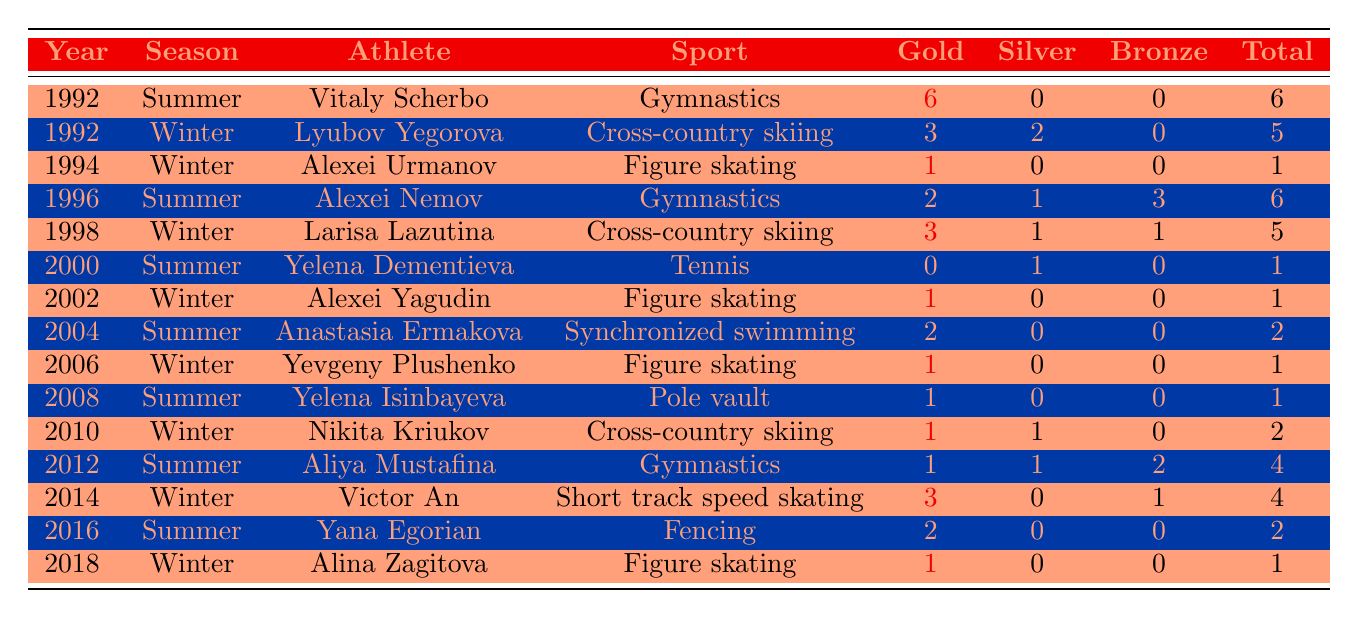What is the total number of gold medals won by Russian athletes in the Summer Olympics? To find the total number of gold medals in the Summer Olympics, we can sum up the Gold column for the rows where the Season is "Summer": 6 (1992) + 2 (1996) + 0 (2000) + 2 (2004) + 1 (2008) + 1 (2012) + 2 (2016) = 14
Answer: 14 Which athlete has the highest total medal count in the Winter Olympics? To identify which athlete has the highest total medal count in the Winter Olympics, we need to look for the maximum value in the Total column for the Season "Winter". The totals are 5 (Lyubov Yegorova), 1 (Alexei Urmanov), 5 (Larisa Lazutina), 1 (Alexei Yagudin), 1 (Yevgeny Plushenko), 2 (Nikita Kriukov), 4 (Victor An), 1 (Alina Zagitova). The highest is 5, held by Lyubov Yegorova and Larisa Lazutina.
Answer: 5 How many more gold medals were won in the Summer Olympics compared to the Winter Olympics? First, we find the total gold medals in Summer Olympics which is 14 (previous calculation). Then, for the Winter Olympics, we sum the Gold column: 3 (Lyubov Yegorova) + 1 (Alexei Urmanov) + 3 (Larisa Lazutina) + 1 (Alexei Yagudin) + 1 (Yevgeny Plushenko) + 1 (Nikita Kriukov) + 3 (Victor An) + 1 (Alina Zagitova) = 12. The difference is 14 - 12 = 2.
Answer: 2 Did any athlete win a gold medal in every season they competed in? We check each athlete in the table for the number of seasons they competed and the number of gold medals: Vitaly Scherbo (1 season, 6 gold), Yelena Dementieva (1 season, 0 gold), Alexei Nemov (1 season, 2 gold), Alexei Yagudin (1 season, 1 gold), and so on. None have competed in multiple seasons and won gold each time. Therefore, the answer is no.
Answer: No What was the total medal count for Aliya Mustafina in the Summer Olympics? For Aliya Mustafina from the Summer Olympics in 2012, her gold, silver, and bronze totals are 1, 1, and 2 respectively. We sum these values: 1 + 1 + 2 = 4.
Answer: 4 